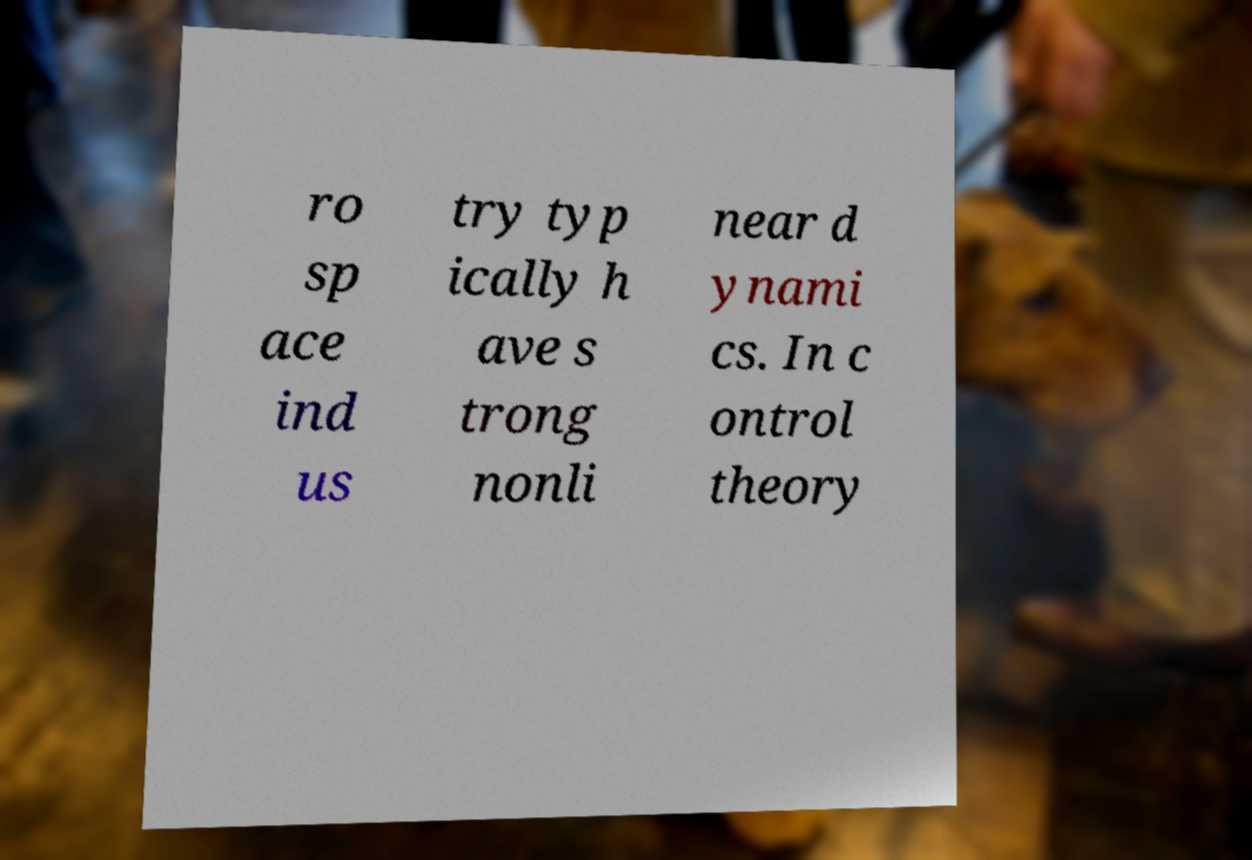Can you accurately transcribe the text from the provided image for me? ro sp ace ind us try typ ically h ave s trong nonli near d ynami cs. In c ontrol theory 